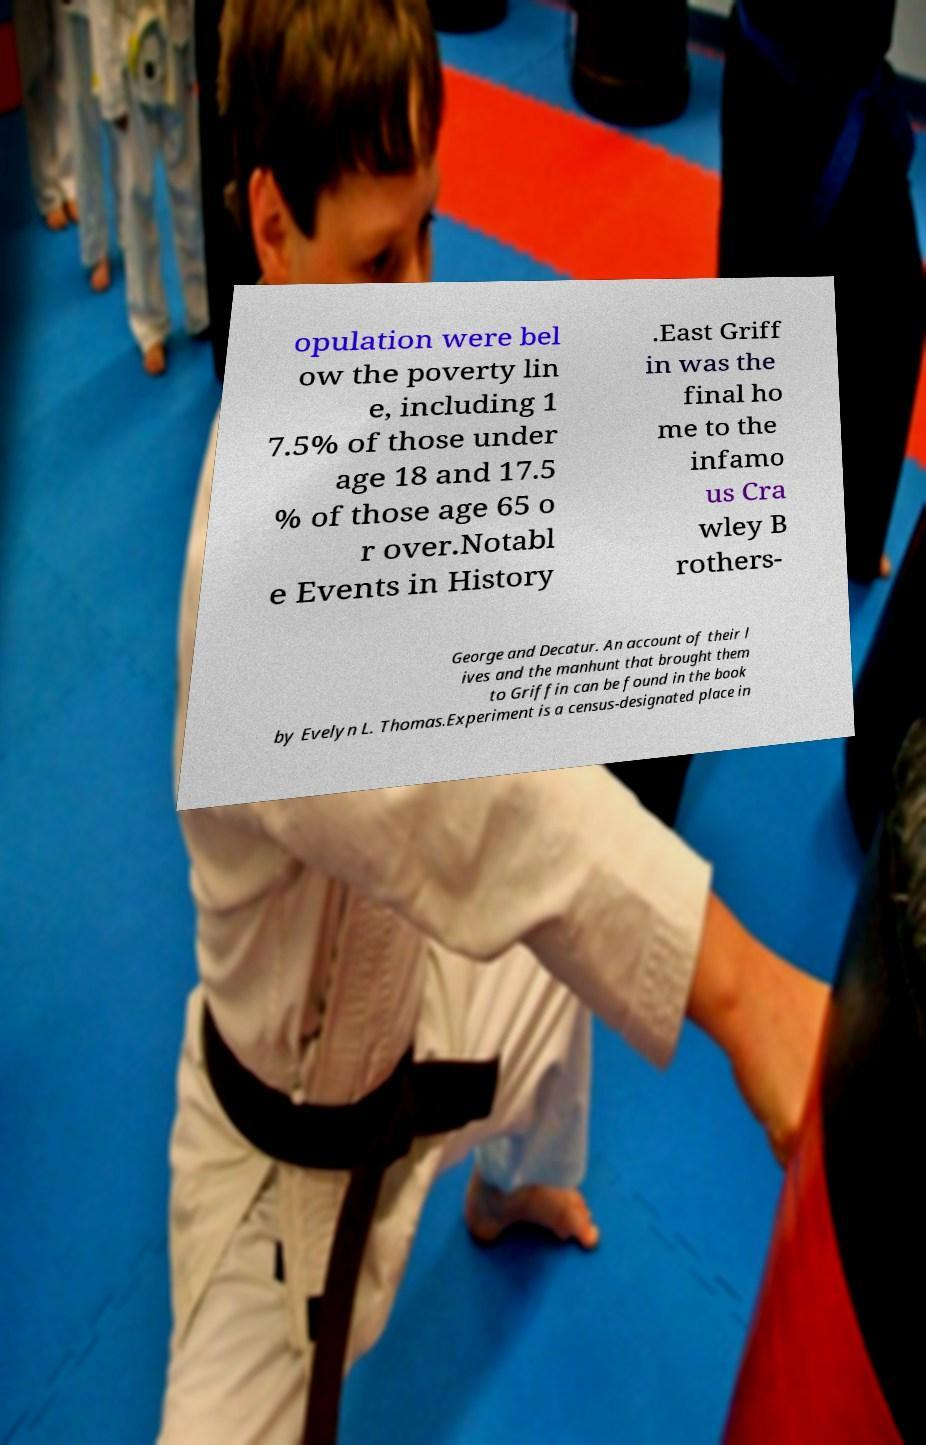Please read and relay the text visible in this image. What does it say? opulation were bel ow the poverty lin e, including 1 7.5% of those under age 18 and 17.5 % of those age 65 o r over.Notabl e Events in History .East Griff in was the final ho me to the infamo us Cra wley B rothers- George and Decatur. An account of their l ives and the manhunt that brought them to Griffin can be found in the book by Evelyn L. Thomas.Experiment is a census-designated place in 